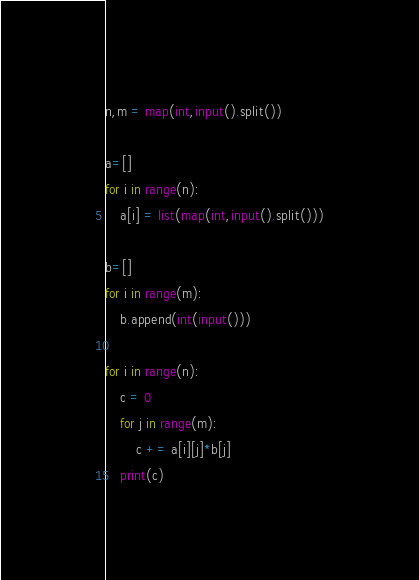<code> <loc_0><loc_0><loc_500><loc_500><_Python_>n,m = map(int,input().split())

a=[]
for i in range(n):
    a[i] = list(map(int,input().split()))

b=[]
for i in range(m):
    b.append(int(input()))
    
for i in range(n):
    c = 0
    for j in range(m):
        c += a[i][j]*b[j]
    print(c)</code> 